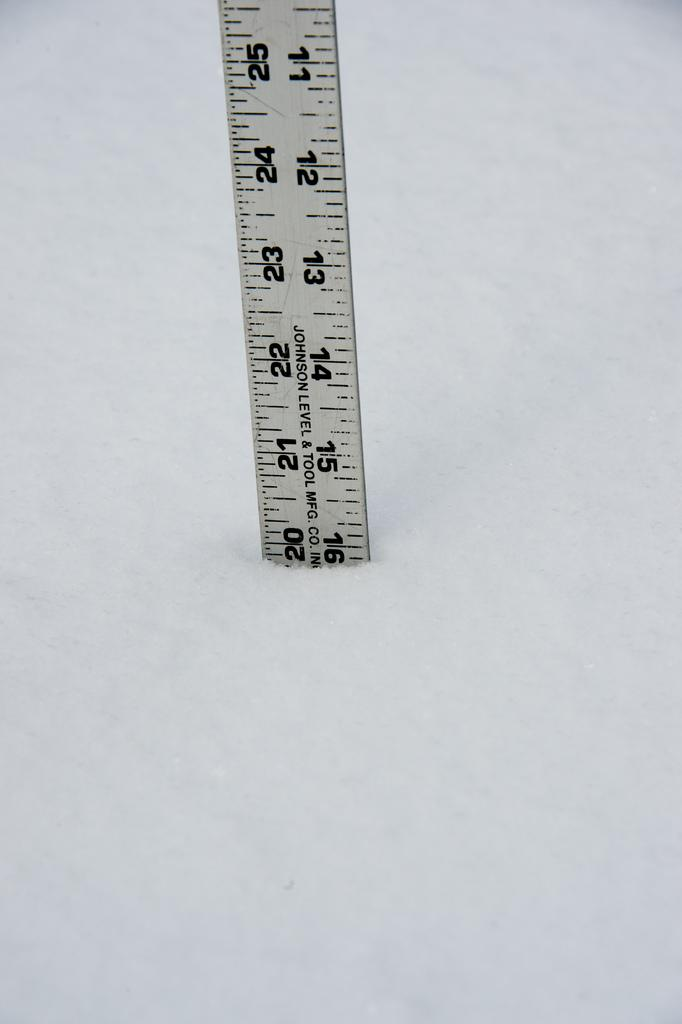<image>
Offer a succinct explanation of the picture presented. A ruler is labeled with the business name Johnson Level & Tool Manufacturing Company. 